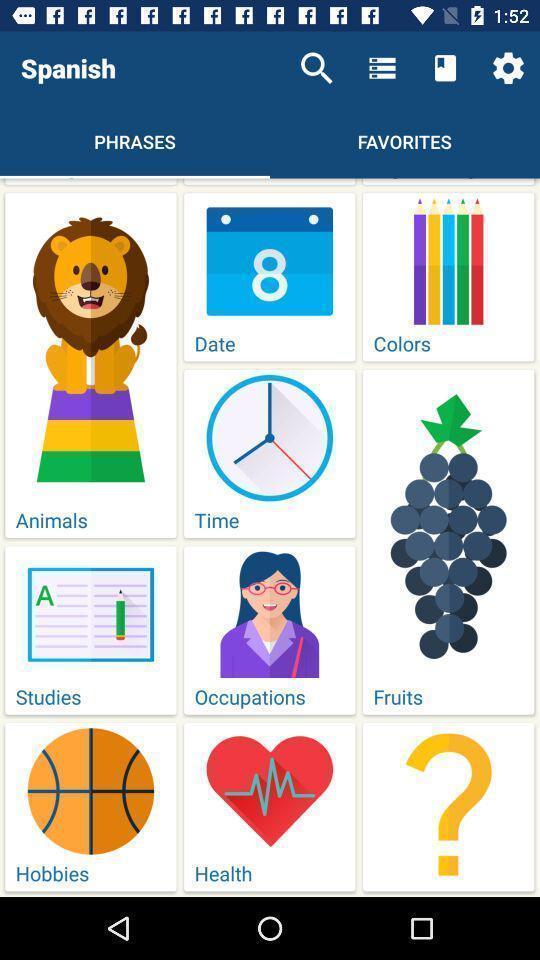Provide a description of this screenshot. Search bar and options in a learning app. 